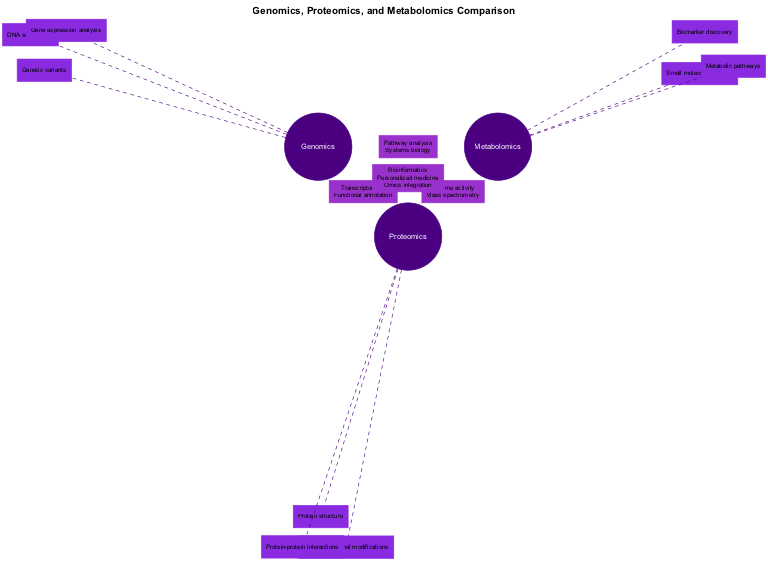What unique element is associated with genomics? The diagram lists "DNA sequencing," "Gene expression analysis," and "Genetic variants" as unique elements for genomics. Therefore, one example is "DNA sequencing."
Answer: DNA sequencing How many unique elements are listed for proteomics? The diagram shows three unique elements listed under proteomics: "Protein structure," "Post-translational modifications," and "Protein-protein interactions." Therefore, the count is three.
Answer: 3 Which shared element is found in both genomics and metabolomics? Referring to the shared elements between genomics and metabolomics, "Pathway analysis" and "Systems biology" are listed. Thus, "Pathway analysis" is one of the elements in both sections.
Answer: Pathway analysis What are the elements shared by all three fields? The diagram specifies that "Bioinformatics," "Personalized medicine," and "Omics integration" are shared among genomics, proteomics, and metabolomics. Listing these components, we can summarize them as such.
Answer: Bioinformatics, Personalized medicine, Omics integration Which omics field focuses on small molecule analysis? The unique elements of metabolomics include "Small molecule analysis," "Metabolic pathways," and "Biomarker discovery." Therefore, the field that focuses on this area is metabolomics.
Answer: Metabolomics What is the relationship between proteomics and metabolomics according to shared elements? The shared elements listed between proteomics and metabolomics include "Enzyme activity" and "Mass spectrometry." This indicates that they intersect at these elements.
Answer: Enzyme activity, Mass spectrometry How many sections are there in the Venn diagram based on the information provided? The diagram outlines seven sections: three unique fields (Genomics, Proteomics, Metabolomics), three shared fields (Genomics & Proteomics, Proteomics & Metabolomics, Genomics & Metabolomics), and one section where all three overlap. Thus, adding these provides a total of seven sections.
Answer: 7 What does the intersection of all three fields emphasize? The intersecting part of the diagram highlights concepts relevant to all three fields, specifically "Bioinformatics," "Personalized medicine," and "Omics integration." These are emphasized as common elements irrespective of the areas.
Answer: Bioinformatics, Personalized medicine, Omics integration Which unique element is specific to metabolomics? The diagram presents the unique elements of metabolomics consisting of "Small molecule analysis," "Metabolic pathways," and "Biomarker discovery." Of these, "Small molecule analysis" is an example specific to metabolomics.
Answer: Small molecule analysis 